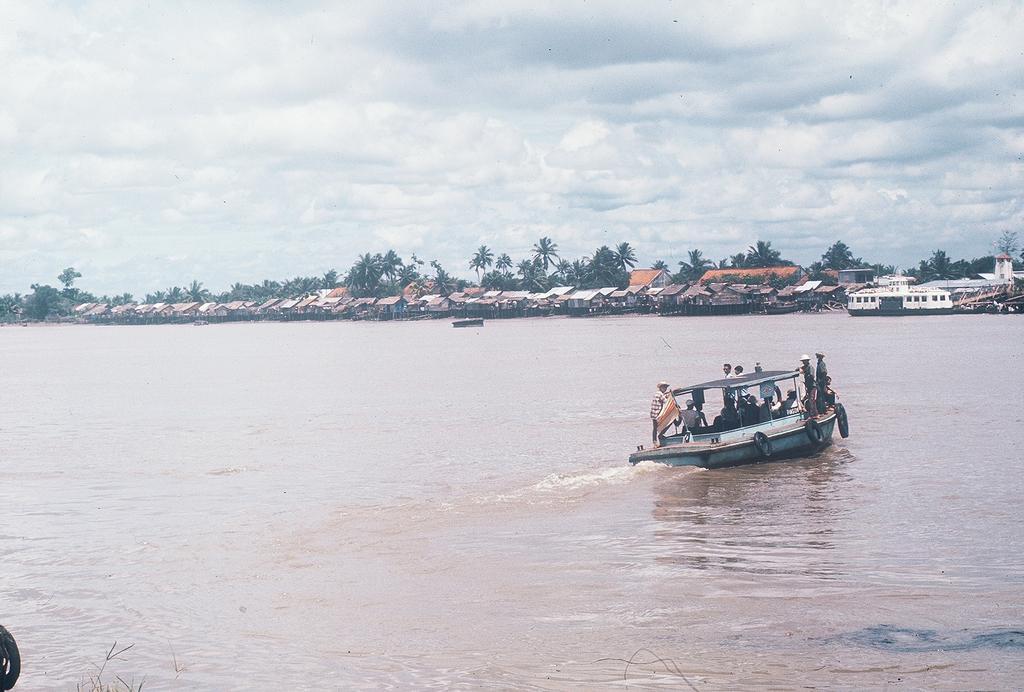Describe this image in one or two sentences. In this picture we can see boats on water and some people on a boat, houses, trees and in the background we can see the sky. 